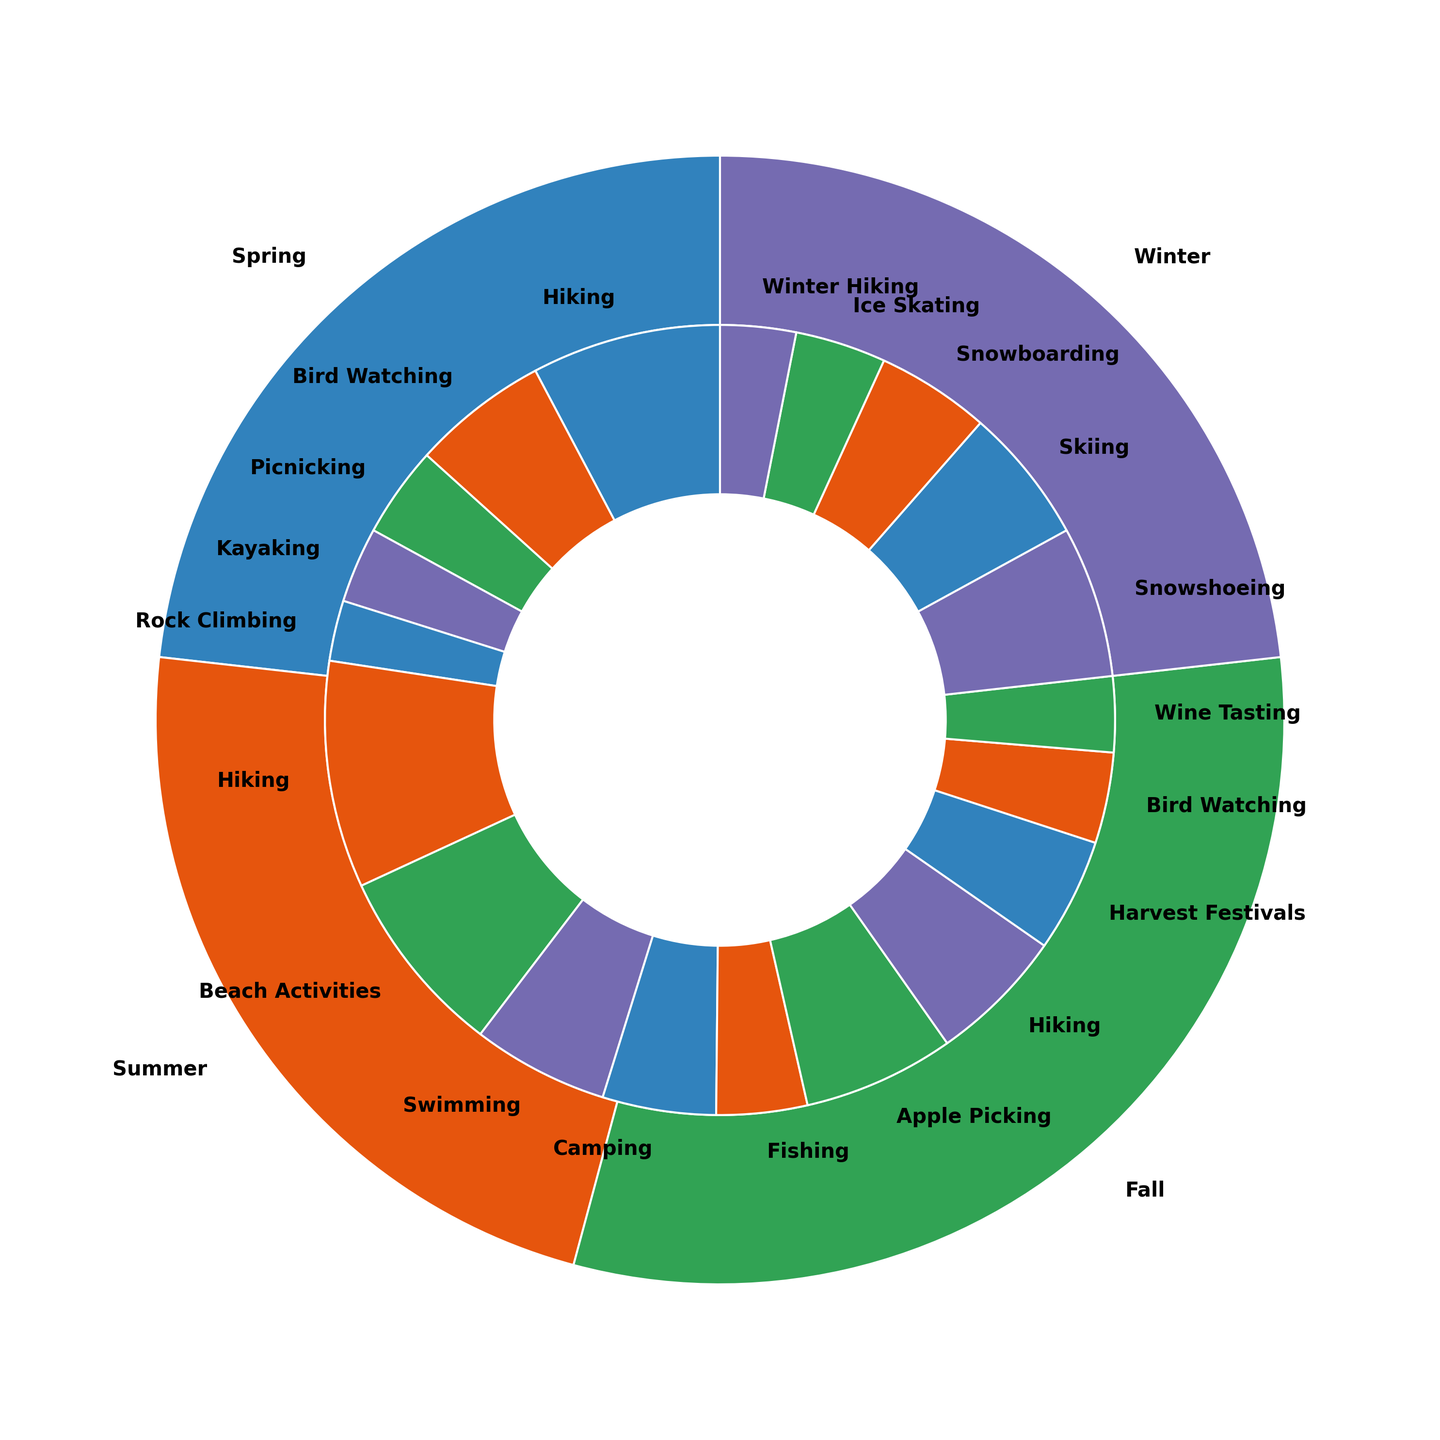Which season has the highest popularity for outdoor activities? By looking at the outer layer of the nested pie chart, we can compare the sizes of the seasonal slices. The season with the largest slice has the highest popularity.
Answer: Summer What is the popularity of hiking in each season? To find this, look at the inner slices labeled "Hiking" for each season's segment and sum their popularity values: 25 in Spring, 30 in Summer, and 18 in Fall.
Answer: 25 in Spring, 30 in Summer, 18 in Fall Is bird watching more popular in Spring or Fall? Find the inner slices labeled "Bird Watching" within the Spring and Fall segments. Compare their sizes: Spring has 18, and Fall has 12.
Answer: Spring Which activity in the Winter season has the lowest popularity? Within the Winter segment, identify and compare the inner slices. The smallest slice represents Winter Hiking with a popularity of 10.
Answer: Winter Hiking Compare the combined popularity of Spring activities to Fall activities. Which is higher? Sum the popularity of all activities in the Spring segment (25+18+12+10+8) and the Fall segment (20+18+15+12+10). Spring totals 73, and Fall totals 75.
Answer: Fall Which activities have the same popularity value of 15? Look for inner slices labeled with 15 in the pie chart, which are Camping (Summer), Snowboarding (Winter), and Harvest Festivals (Fall).
Answer: Camping, Snowboarding, Harvest Festivals What is the second most popular activity in the Summer? Identify the slices within the Summer segment and order them by size. The second largest slice after Hiking (30) is Beach Activities (25).
Answer: Beach Activities How does the popularity of Kayaking in Spring compare to Fishing in Summer? Locate the inner slices for Kayaking within Spring (10) and Fishing in Summer (12). Compare the sizes. Fishing is slightly more popular.
Answer: Fishing is more popular Which season has the greatest variety of activities listed in the chart? Count the number of different inner slices within each seasonal segment. Spring and Summer each have 5 activities, Fall has 5, and Winter has 5.
Answer: All seasons have equal variety What's the total popularity of winter sports activities (Snowshoeing, Skiing, Snowboarding, Ice Skating)? Sum the popularity values for Snowshoeing (20), Skiing (18), Snowboarding (15), and Ice Skating (12): 20 + 18 + 15 + 12 = 65.
Answer: 65 